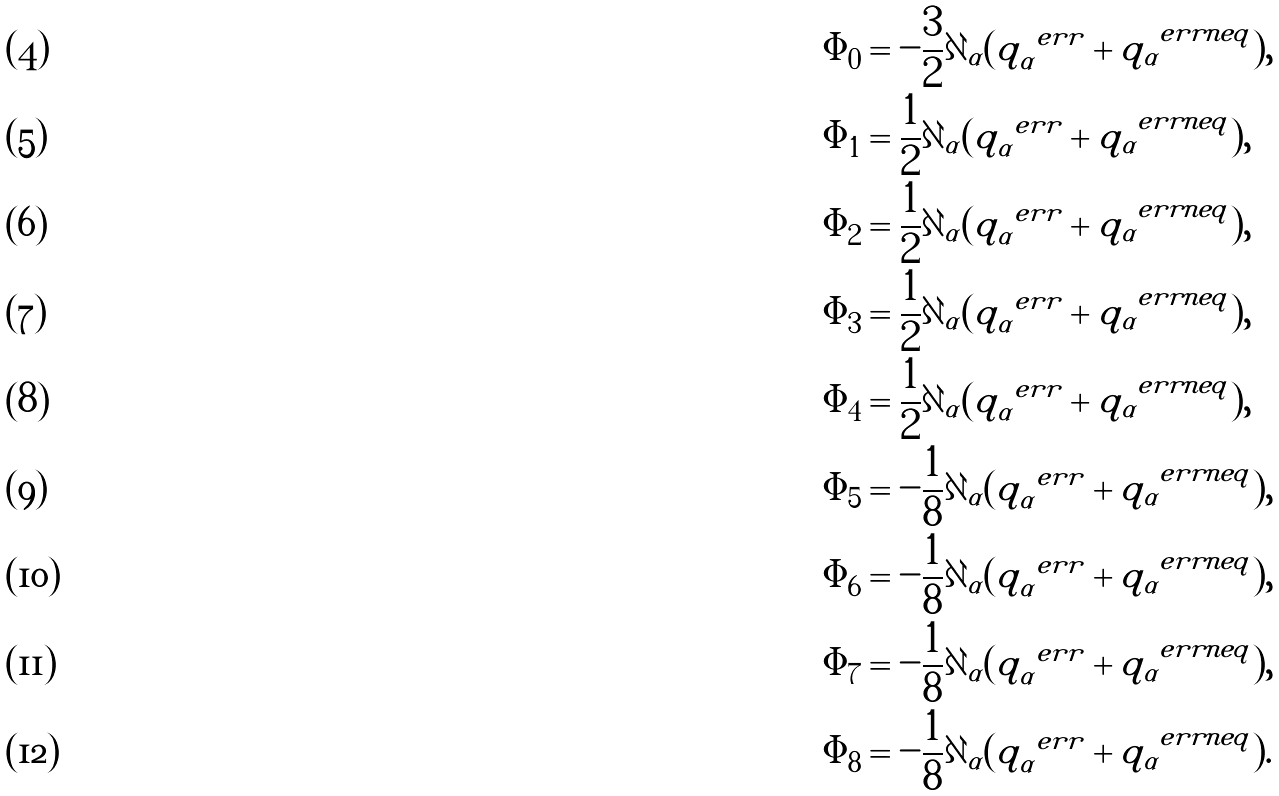Convert formula to latex. <formula><loc_0><loc_0><loc_500><loc_500>\Phi _ { 0 } & = - \frac { 3 } { 2 } \partial _ { \alpha } ( q _ { \alpha } ^ { \ e r r } + q _ { \alpha } ^ { \ e r r n e q } ) , \\ \Phi _ { 1 } & = \frac { 1 } { 2 } { \partial _ { \alpha } ( q _ { \alpha } ^ { \ e r r } + q _ { \alpha } ^ { \ e r r n e q } ) } , \\ \Phi _ { 2 } & = \frac { 1 } { 2 } \partial _ { \alpha } ( q _ { \alpha } ^ { \ e r r } + q _ { \alpha } ^ { \ e r r n e q } ) , \\ \Phi _ { 3 } & = \frac { 1 } { 2 } \partial _ { \alpha } ( q _ { \alpha } ^ { \ e r r } + q _ { \alpha } ^ { \ e r r n e q } ) , \\ \Phi _ { 4 } & = \frac { 1 } { 2 } \partial _ { \alpha } ( q _ { \alpha } ^ { \ e r r } + q _ { \alpha } ^ { \ e r r n e q } ) , \\ \Phi _ { 5 } & = - \frac { 1 } { 8 } \partial _ { \alpha } ( q _ { \alpha } ^ { \ e r r } + q _ { \alpha } ^ { \ e r r n e q } ) , \\ \Phi _ { 6 } & = - \frac { 1 } { 8 } \partial _ { \alpha } ( q _ { \alpha } ^ { \ e r r } + q _ { \alpha } ^ { \ e r r n e q } ) , \\ \Phi _ { 7 } & = - \frac { 1 } { 8 } \partial _ { \alpha } ( q _ { \alpha } ^ { \ e r r } + q _ { \alpha } ^ { \ e r r n e q } ) , \\ \Phi _ { 8 } & = - \frac { 1 } { 8 } \partial _ { \alpha } ( q _ { \alpha } ^ { \ e r r } + q _ { \alpha } ^ { \ e r r n e q } ) .</formula> 